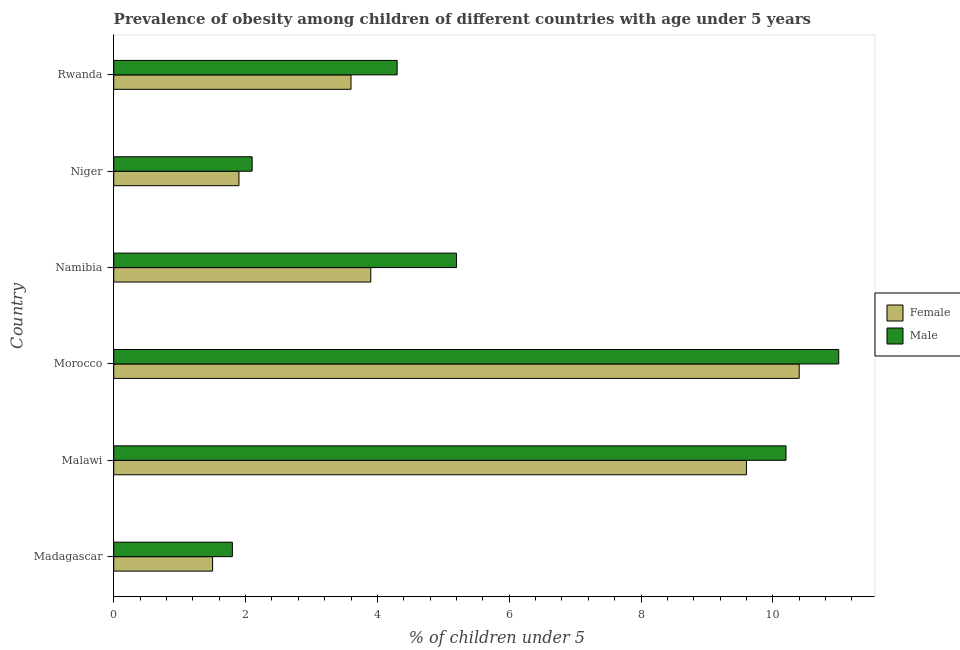How many different coloured bars are there?
Provide a short and direct response. 2. How many groups of bars are there?
Make the answer very short. 6. What is the label of the 3rd group of bars from the top?
Your answer should be very brief. Namibia. What is the percentage of obese male children in Niger?
Your answer should be very brief. 2.1. Across all countries, what is the minimum percentage of obese male children?
Offer a terse response. 1.8. In which country was the percentage of obese female children maximum?
Ensure brevity in your answer.  Morocco. In which country was the percentage of obese male children minimum?
Ensure brevity in your answer.  Madagascar. What is the total percentage of obese male children in the graph?
Your response must be concise. 34.6. What is the difference between the percentage of obese male children in Niger and the percentage of obese female children in Madagascar?
Offer a very short reply. 0.6. What is the average percentage of obese female children per country?
Your answer should be compact. 5.15. What is the difference between the percentage of obese male children and percentage of obese female children in Rwanda?
Provide a short and direct response. 0.7. In how many countries, is the percentage of obese female children greater than 2 %?
Your answer should be very brief. 4. What is the ratio of the percentage of obese male children in Niger to that in Rwanda?
Keep it short and to the point. 0.49. Is the difference between the percentage of obese male children in Madagascar and Rwanda greater than the difference between the percentage of obese female children in Madagascar and Rwanda?
Provide a succinct answer. No. What is the difference between the highest and the lowest percentage of obese male children?
Give a very brief answer. 9.2. Is the sum of the percentage of obese male children in Madagascar and Namibia greater than the maximum percentage of obese female children across all countries?
Give a very brief answer. No. What does the 2nd bar from the top in Morocco represents?
Offer a very short reply. Female. How many bars are there?
Offer a terse response. 12. Are all the bars in the graph horizontal?
Give a very brief answer. Yes. What is the difference between two consecutive major ticks on the X-axis?
Your answer should be compact. 2. Does the graph contain any zero values?
Ensure brevity in your answer.  No. Does the graph contain grids?
Offer a terse response. No. What is the title of the graph?
Your answer should be compact. Prevalence of obesity among children of different countries with age under 5 years. Does "Exports" appear as one of the legend labels in the graph?
Offer a very short reply. No. What is the label or title of the X-axis?
Offer a very short reply.  % of children under 5. What is the label or title of the Y-axis?
Offer a very short reply. Country. What is the  % of children under 5 of Female in Madagascar?
Your response must be concise. 1.5. What is the  % of children under 5 in Male in Madagascar?
Ensure brevity in your answer.  1.8. What is the  % of children under 5 of Female in Malawi?
Provide a short and direct response. 9.6. What is the  % of children under 5 in Male in Malawi?
Provide a short and direct response. 10.2. What is the  % of children under 5 of Female in Morocco?
Offer a very short reply. 10.4. What is the  % of children under 5 in Female in Namibia?
Provide a succinct answer. 3.9. What is the  % of children under 5 of Male in Namibia?
Your response must be concise. 5.2. What is the  % of children under 5 in Female in Niger?
Your response must be concise. 1.9. What is the  % of children under 5 in Male in Niger?
Offer a very short reply. 2.1. What is the  % of children under 5 in Female in Rwanda?
Your response must be concise. 3.6. What is the  % of children under 5 of Male in Rwanda?
Offer a terse response. 4.3. Across all countries, what is the maximum  % of children under 5 of Female?
Offer a terse response. 10.4. Across all countries, what is the minimum  % of children under 5 in Female?
Provide a short and direct response. 1.5. Across all countries, what is the minimum  % of children under 5 in Male?
Offer a very short reply. 1.8. What is the total  % of children under 5 of Female in the graph?
Your answer should be compact. 30.9. What is the total  % of children under 5 of Male in the graph?
Make the answer very short. 34.6. What is the difference between the  % of children under 5 of Female in Madagascar and that in Malawi?
Your answer should be very brief. -8.1. What is the difference between the  % of children under 5 in Male in Madagascar and that in Morocco?
Ensure brevity in your answer.  -9.2. What is the difference between the  % of children under 5 in Female in Madagascar and that in Namibia?
Your response must be concise. -2.4. What is the difference between the  % of children under 5 of Female in Madagascar and that in Niger?
Make the answer very short. -0.4. What is the difference between the  % of children under 5 in Male in Madagascar and that in Niger?
Offer a very short reply. -0.3. What is the difference between the  % of children under 5 of Male in Madagascar and that in Rwanda?
Give a very brief answer. -2.5. What is the difference between the  % of children under 5 in Male in Malawi and that in Morocco?
Keep it short and to the point. -0.8. What is the difference between the  % of children under 5 of Female in Malawi and that in Namibia?
Your answer should be compact. 5.7. What is the difference between the  % of children under 5 in Male in Malawi and that in Namibia?
Give a very brief answer. 5. What is the difference between the  % of children under 5 in Male in Malawi and that in Niger?
Ensure brevity in your answer.  8.1. What is the difference between the  % of children under 5 of Male in Malawi and that in Rwanda?
Your answer should be compact. 5.9. What is the difference between the  % of children under 5 of Female in Morocco and that in Namibia?
Provide a short and direct response. 6.5. What is the difference between the  % of children under 5 in Male in Morocco and that in Namibia?
Your answer should be compact. 5.8. What is the difference between the  % of children under 5 of Male in Morocco and that in Niger?
Your answer should be very brief. 8.9. What is the difference between the  % of children under 5 of Female in Morocco and that in Rwanda?
Make the answer very short. 6.8. What is the difference between the  % of children under 5 of Male in Namibia and that in Rwanda?
Offer a terse response. 0.9. What is the difference between the  % of children under 5 in Female in Madagascar and the  % of children under 5 in Male in Malawi?
Your answer should be compact. -8.7. What is the difference between the  % of children under 5 in Female in Malawi and the  % of children under 5 in Male in Morocco?
Offer a terse response. -1.4. What is the difference between the  % of children under 5 of Female in Malawi and the  % of children under 5 of Male in Namibia?
Your response must be concise. 4.4. What is the difference between the  % of children under 5 of Female in Malawi and the  % of children under 5 of Male in Niger?
Provide a succinct answer. 7.5. What is the difference between the  % of children under 5 of Female in Malawi and the  % of children under 5 of Male in Rwanda?
Provide a succinct answer. 5.3. What is the difference between the  % of children under 5 of Female in Morocco and the  % of children under 5 of Male in Rwanda?
Your answer should be compact. 6.1. What is the difference between the  % of children under 5 in Female in Namibia and the  % of children under 5 in Male in Rwanda?
Provide a succinct answer. -0.4. What is the difference between the  % of children under 5 in Female in Niger and the  % of children under 5 in Male in Rwanda?
Keep it short and to the point. -2.4. What is the average  % of children under 5 of Female per country?
Your answer should be very brief. 5.15. What is the average  % of children under 5 of Male per country?
Make the answer very short. 5.77. What is the difference between the  % of children under 5 in Female and  % of children under 5 in Male in Madagascar?
Give a very brief answer. -0.3. What is the difference between the  % of children under 5 in Female and  % of children under 5 in Male in Malawi?
Provide a short and direct response. -0.6. What is the difference between the  % of children under 5 in Female and  % of children under 5 in Male in Namibia?
Offer a terse response. -1.3. What is the difference between the  % of children under 5 of Female and  % of children under 5 of Male in Niger?
Offer a terse response. -0.2. What is the ratio of the  % of children under 5 in Female in Madagascar to that in Malawi?
Ensure brevity in your answer.  0.16. What is the ratio of the  % of children under 5 in Male in Madagascar to that in Malawi?
Provide a short and direct response. 0.18. What is the ratio of the  % of children under 5 of Female in Madagascar to that in Morocco?
Make the answer very short. 0.14. What is the ratio of the  % of children under 5 of Male in Madagascar to that in Morocco?
Your answer should be compact. 0.16. What is the ratio of the  % of children under 5 in Female in Madagascar to that in Namibia?
Your answer should be very brief. 0.38. What is the ratio of the  % of children under 5 of Male in Madagascar to that in Namibia?
Your answer should be very brief. 0.35. What is the ratio of the  % of children under 5 of Female in Madagascar to that in Niger?
Keep it short and to the point. 0.79. What is the ratio of the  % of children under 5 in Female in Madagascar to that in Rwanda?
Provide a succinct answer. 0.42. What is the ratio of the  % of children under 5 of Male in Madagascar to that in Rwanda?
Give a very brief answer. 0.42. What is the ratio of the  % of children under 5 in Female in Malawi to that in Morocco?
Your answer should be very brief. 0.92. What is the ratio of the  % of children under 5 of Male in Malawi to that in Morocco?
Keep it short and to the point. 0.93. What is the ratio of the  % of children under 5 in Female in Malawi to that in Namibia?
Offer a very short reply. 2.46. What is the ratio of the  % of children under 5 in Male in Malawi to that in Namibia?
Keep it short and to the point. 1.96. What is the ratio of the  % of children under 5 of Female in Malawi to that in Niger?
Offer a terse response. 5.05. What is the ratio of the  % of children under 5 in Male in Malawi to that in Niger?
Make the answer very short. 4.86. What is the ratio of the  % of children under 5 in Female in Malawi to that in Rwanda?
Provide a short and direct response. 2.67. What is the ratio of the  % of children under 5 of Male in Malawi to that in Rwanda?
Your answer should be very brief. 2.37. What is the ratio of the  % of children under 5 in Female in Morocco to that in Namibia?
Provide a short and direct response. 2.67. What is the ratio of the  % of children under 5 in Male in Morocco to that in Namibia?
Your answer should be very brief. 2.12. What is the ratio of the  % of children under 5 of Female in Morocco to that in Niger?
Ensure brevity in your answer.  5.47. What is the ratio of the  % of children under 5 in Male in Morocco to that in Niger?
Your response must be concise. 5.24. What is the ratio of the  % of children under 5 in Female in Morocco to that in Rwanda?
Provide a succinct answer. 2.89. What is the ratio of the  % of children under 5 in Male in Morocco to that in Rwanda?
Offer a very short reply. 2.56. What is the ratio of the  % of children under 5 in Female in Namibia to that in Niger?
Provide a short and direct response. 2.05. What is the ratio of the  % of children under 5 of Male in Namibia to that in Niger?
Give a very brief answer. 2.48. What is the ratio of the  % of children under 5 in Female in Namibia to that in Rwanda?
Your answer should be very brief. 1.08. What is the ratio of the  % of children under 5 in Male in Namibia to that in Rwanda?
Your response must be concise. 1.21. What is the ratio of the  % of children under 5 of Female in Niger to that in Rwanda?
Your response must be concise. 0.53. What is the ratio of the  % of children under 5 in Male in Niger to that in Rwanda?
Ensure brevity in your answer.  0.49. What is the difference between the highest and the second highest  % of children under 5 in Male?
Your response must be concise. 0.8. What is the difference between the highest and the lowest  % of children under 5 in Female?
Give a very brief answer. 8.9. What is the difference between the highest and the lowest  % of children under 5 in Male?
Your response must be concise. 9.2. 